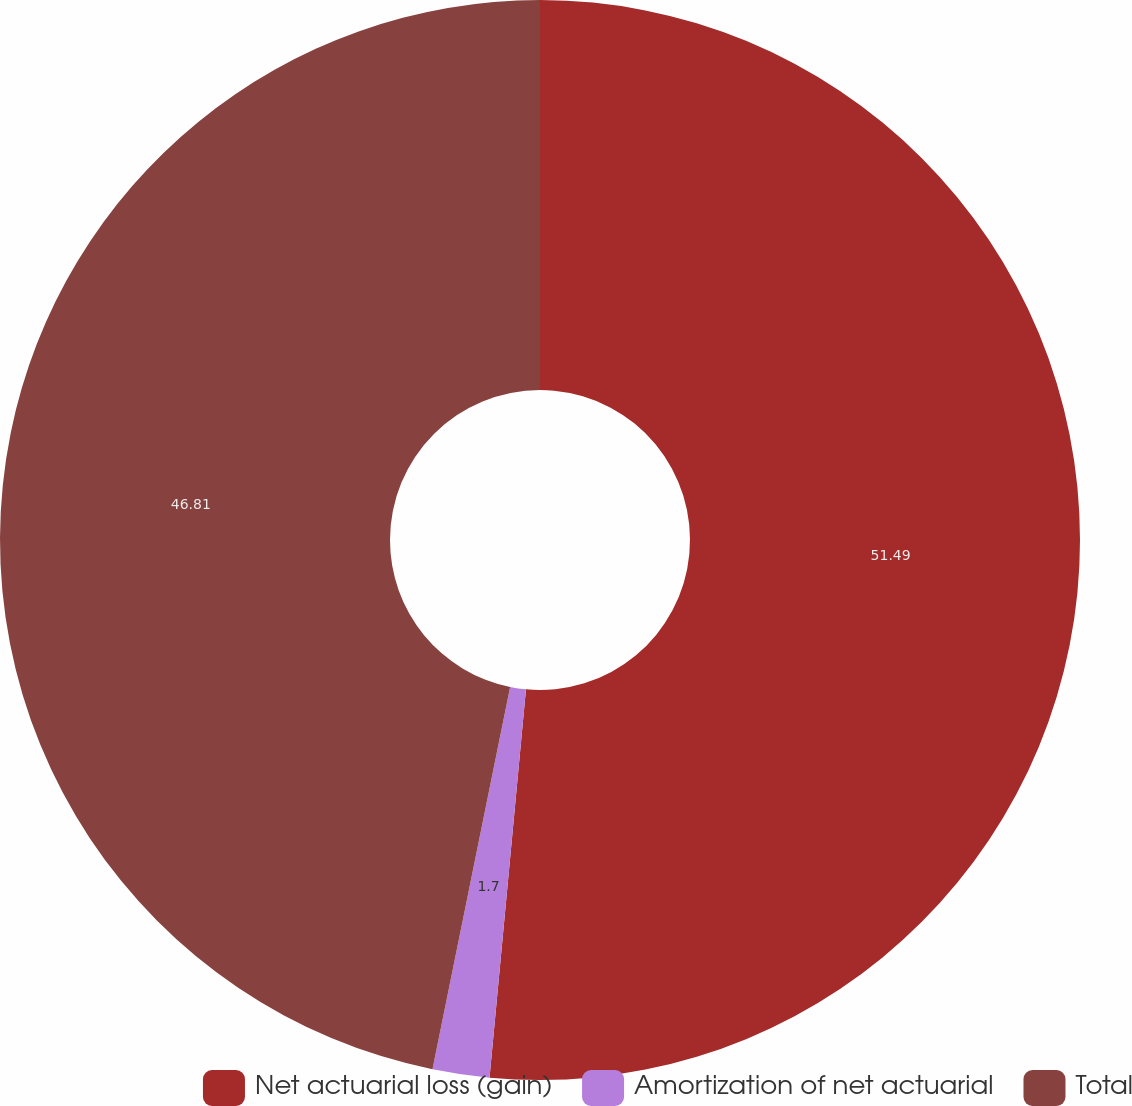Convert chart to OTSL. <chart><loc_0><loc_0><loc_500><loc_500><pie_chart><fcel>Net actuarial loss (gain)<fcel>Amortization of net actuarial<fcel>Total<nl><fcel>51.49%<fcel>1.7%<fcel>46.81%<nl></chart> 